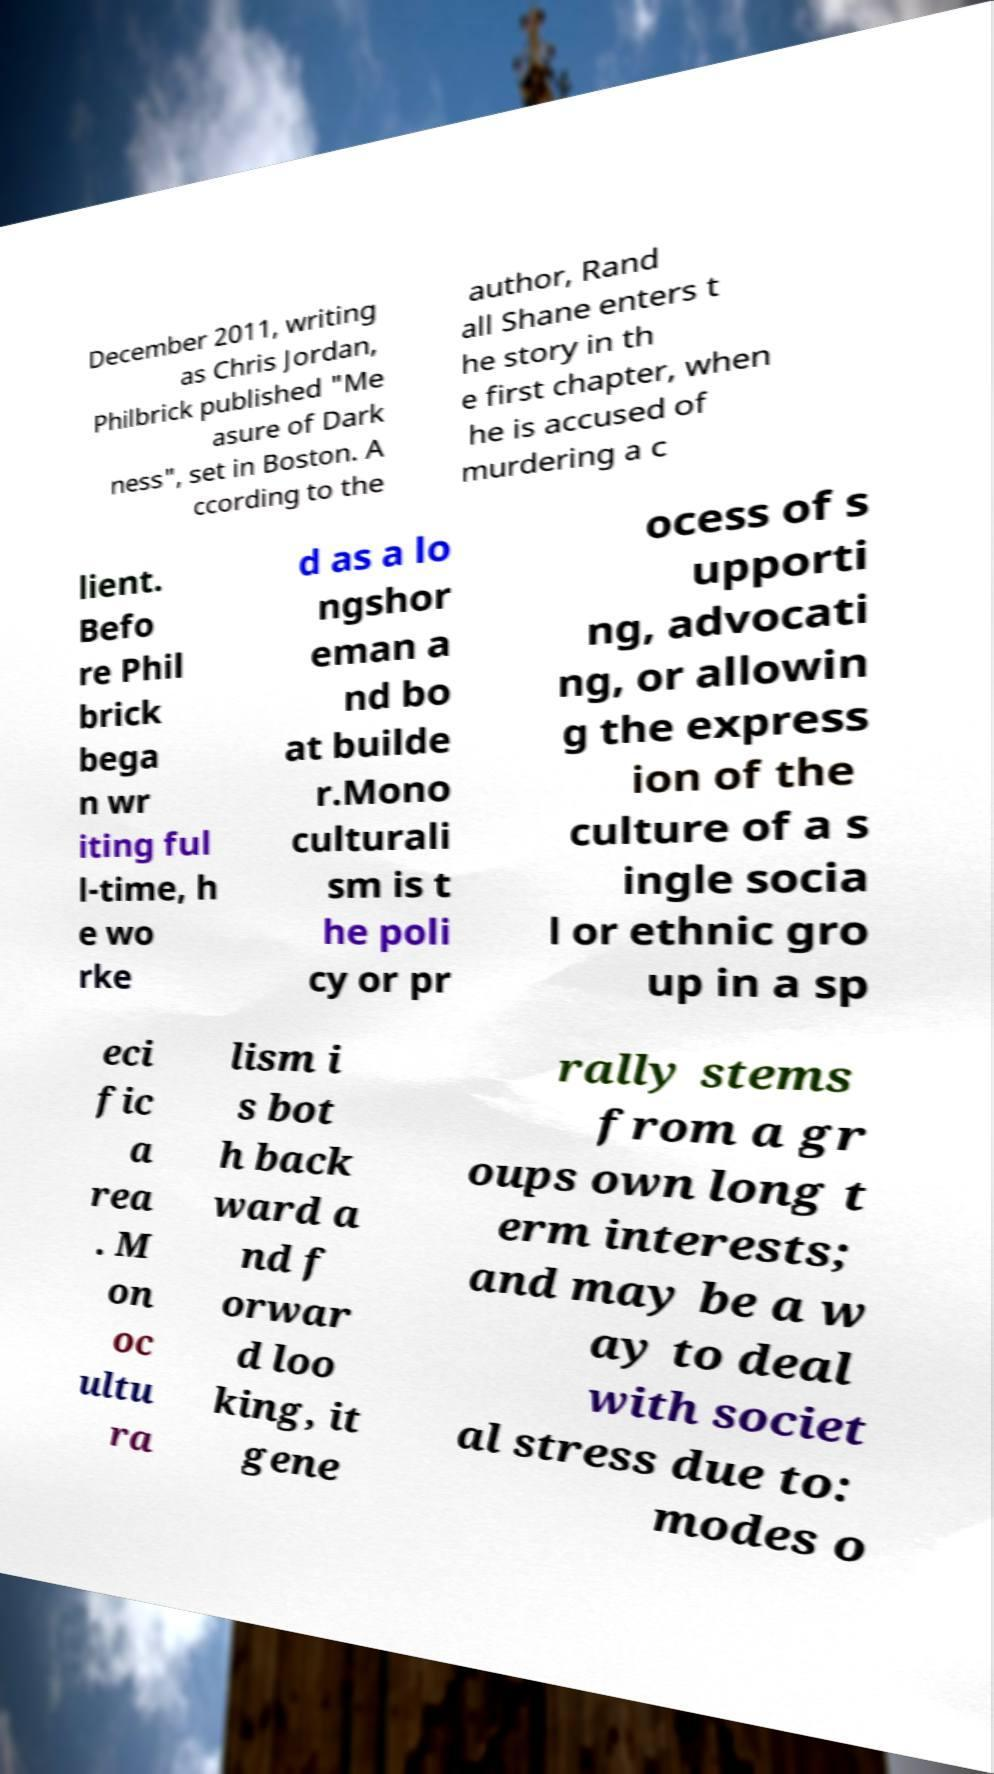I need the written content from this picture converted into text. Can you do that? December 2011, writing as Chris Jordan, Philbrick published "Me asure of Dark ness", set in Boston. A ccording to the author, Rand all Shane enters t he story in th e first chapter, when he is accused of murdering a c lient. Befo re Phil brick bega n wr iting ful l-time, h e wo rke d as a lo ngshor eman a nd bo at builde r.Mono culturali sm is t he poli cy or pr ocess of s upporti ng, advocati ng, or allowin g the express ion of the culture of a s ingle socia l or ethnic gro up in a sp eci fic a rea . M on oc ultu ra lism i s bot h back ward a nd f orwar d loo king, it gene rally stems from a gr oups own long t erm interests; and may be a w ay to deal with societ al stress due to: modes o 